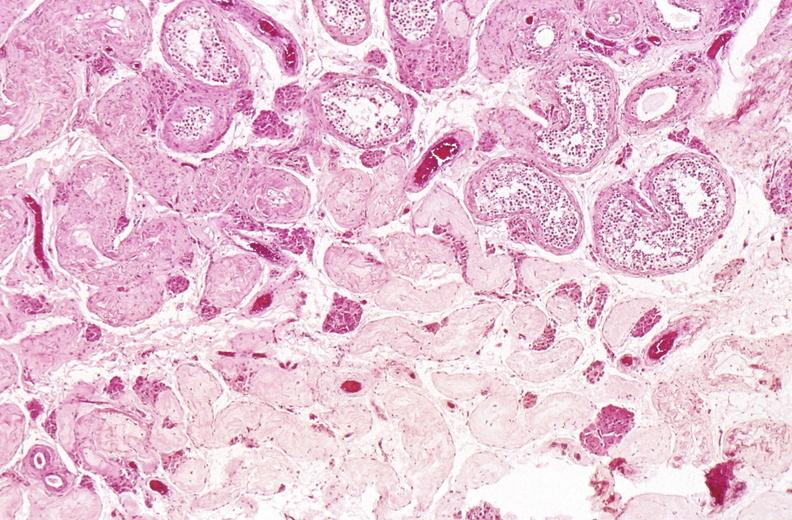what does this image show?
Answer the question using a single word or phrase. Testes 